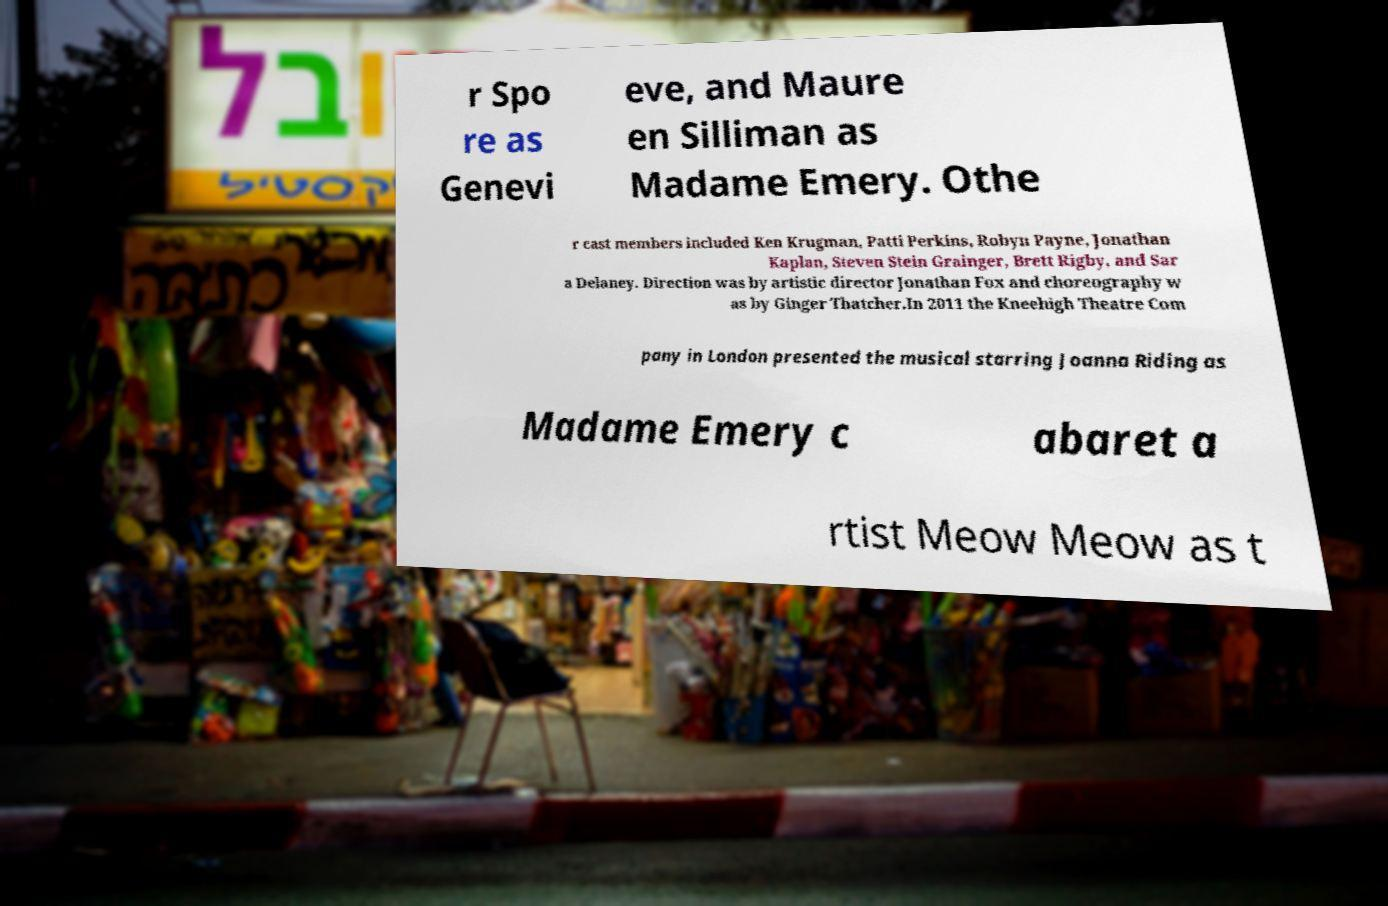Please read and relay the text visible in this image. What does it say? r Spo re as Genevi eve, and Maure en Silliman as Madame Emery. Othe r cast members included Ken Krugman, Patti Perkins, Robyn Payne, Jonathan Kaplan, Steven Stein Grainger, Brett Rigby, and Sar a Delaney. Direction was by artistic director Jonathan Fox and choreography w as by Ginger Thatcher.In 2011 the Kneehigh Theatre Com pany in London presented the musical starring Joanna Riding as Madame Emery c abaret a rtist Meow Meow as t 